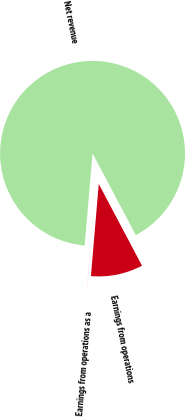<chart> <loc_0><loc_0><loc_500><loc_500><pie_chart><fcel>Net revenue<fcel>Earnings from operations<fcel>Earnings from operations as a<nl><fcel>90.89%<fcel>9.1%<fcel>0.01%<nl></chart> 